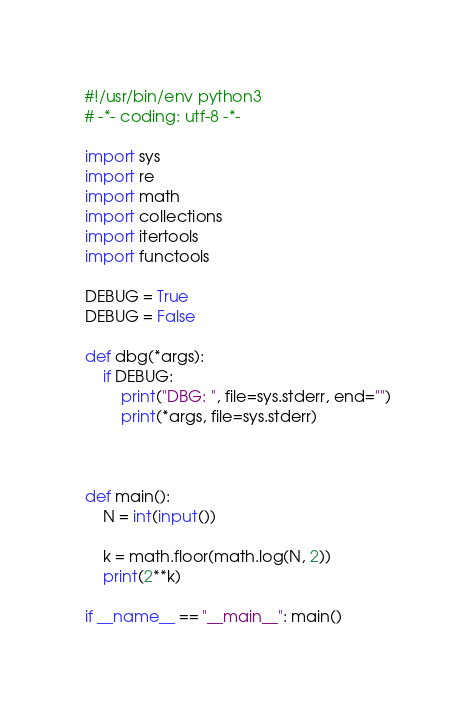<code> <loc_0><loc_0><loc_500><loc_500><_Python_>#!/usr/bin/env python3
# -*- coding: utf-8 -*-

import sys
import re
import math
import collections
import itertools
import functools

DEBUG = True
DEBUG = False

def dbg(*args):
    if DEBUG:
        print("DBG: ", file=sys.stderr, end="")
        print(*args, file=sys.stderr)



def main():
    N = int(input())

    k = math.floor(math.log(N, 2))
    print(2**k)

if __name__ == "__main__": main()
</code> 